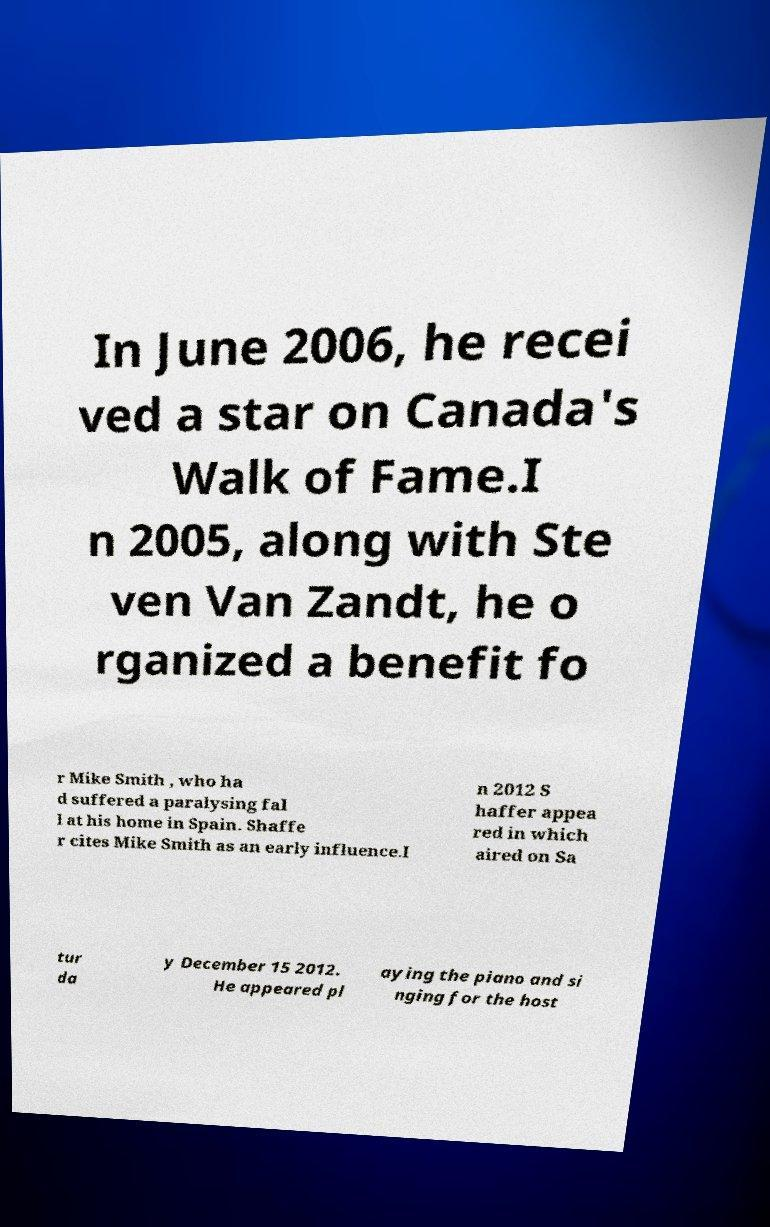Could you extract and type out the text from this image? In June 2006, he recei ved a star on Canada's Walk of Fame.I n 2005, along with Ste ven Van Zandt, he o rganized a benefit fo r Mike Smith , who ha d suffered a paralysing fal l at his home in Spain. Shaffe r cites Mike Smith as an early influence.I n 2012 S haffer appea red in which aired on Sa tur da y December 15 2012. He appeared pl aying the piano and si nging for the host 